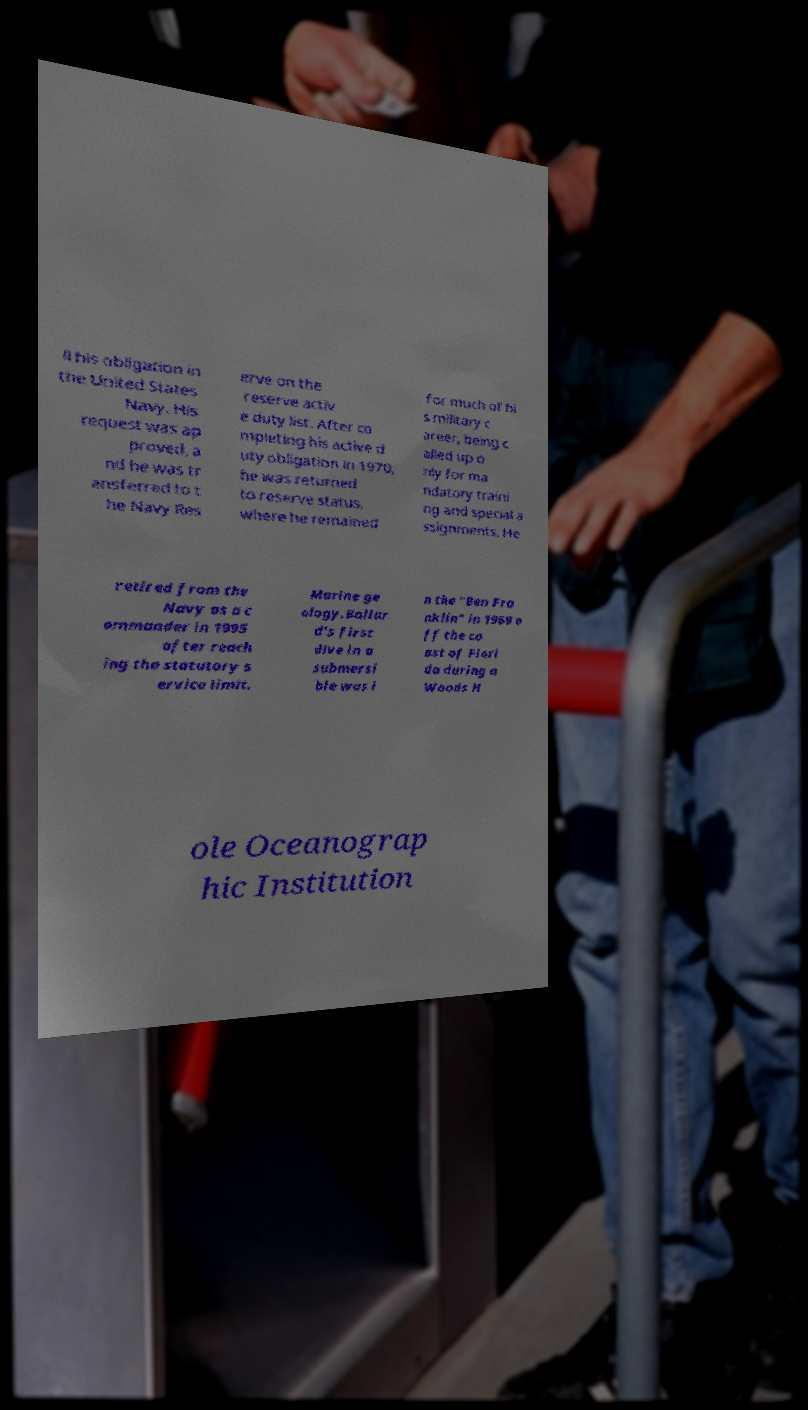Could you extract and type out the text from this image? ll his obligation in the United States Navy. His request was ap proved, a nd he was tr ansferred to t he Navy Res erve on the reserve activ e duty list. After co mpleting his active d uty obligation in 1970, he was returned to reserve status, where he remained for much of hi s military c areer, being c alled up o nly for ma ndatory traini ng and special a ssignments. He retired from the Navy as a c ommander in 1995 after reach ing the statutory s ervice limit. Marine ge ology.Ballar d's first dive in a submersi ble was i n the "Ben Fra nklin" in 1969 o ff the co ast of Flori da during a Woods H ole Oceanograp hic Institution 